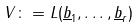Convert formula to latex. <formula><loc_0><loc_0><loc_500><loc_500>V \colon = L ( \underline { b } _ { 1 } , \dots , \underline { b } _ { r } )</formula> 